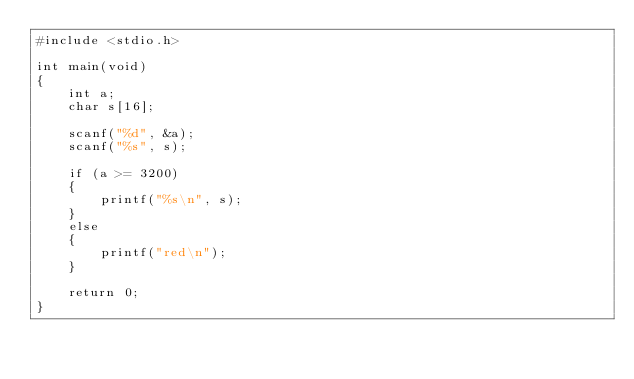<code> <loc_0><loc_0><loc_500><loc_500><_C_>#include <stdio.h>

int main(void)
{
    int a;
    char s[16];

    scanf("%d", &a);
    scanf("%s", s);

    if (a >= 3200)
    {
        printf("%s\n", s);
    }
    else
    {
        printf("red\n");
    }

    return 0;
}</code> 